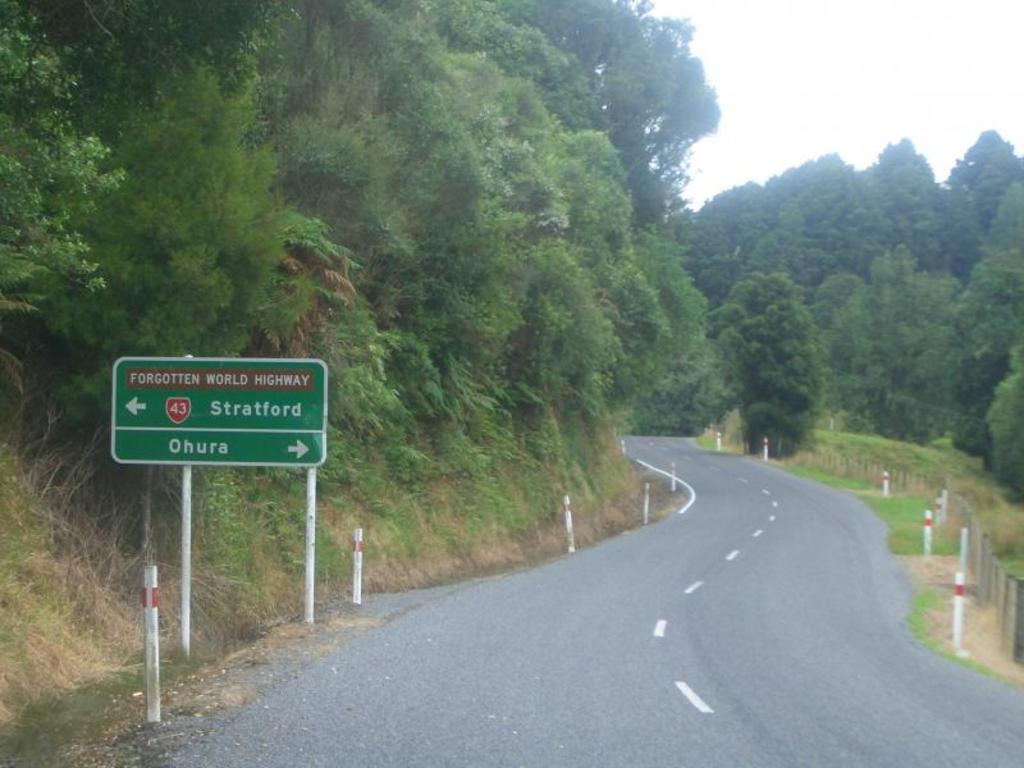<image>
Describe the image concisely. a sign next to the road that says Stratford 